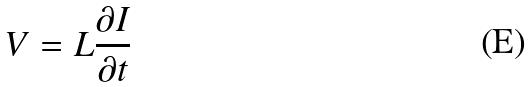<formula> <loc_0><loc_0><loc_500><loc_500>V = L \frac { \partial I } { \partial t }</formula> 